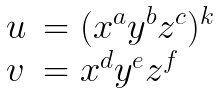<formula> <loc_0><loc_0><loc_500><loc_500>\begin{array} { l l } u & = ( x ^ { a } y ^ { b } z ^ { c } ) ^ { k } \\ v & = x ^ { d } y ^ { e } z ^ { f } \end{array}</formula> 